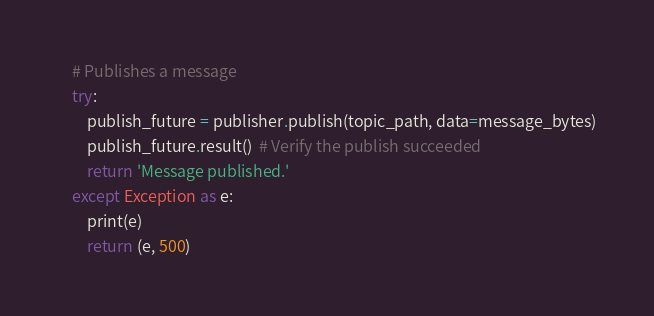Convert code to text. <code><loc_0><loc_0><loc_500><loc_500><_Python_>
    # Publishes a message
    try:
        publish_future = publisher.publish(topic_path, data=message_bytes)
        publish_future.result()  # Verify the publish succeeded
        return 'Message published.'
    except Exception as e:
        print(e)
        return (e, 500)</code> 